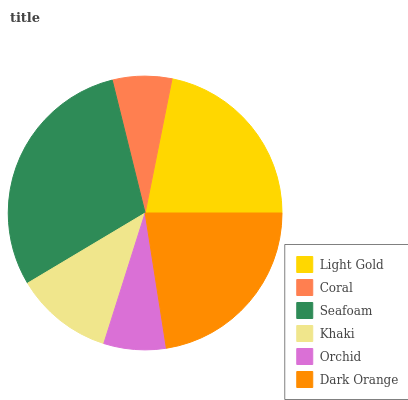Is Coral the minimum?
Answer yes or no. Yes. Is Seafoam the maximum?
Answer yes or no. Yes. Is Seafoam the minimum?
Answer yes or no. No. Is Coral the maximum?
Answer yes or no. No. Is Seafoam greater than Coral?
Answer yes or no. Yes. Is Coral less than Seafoam?
Answer yes or no. Yes. Is Coral greater than Seafoam?
Answer yes or no. No. Is Seafoam less than Coral?
Answer yes or no. No. Is Light Gold the high median?
Answer yes or no. Yes. Is Khaki the low median?
Answer yes or no. Yes. Is Orchid the high median?
Answer yes or no. No. Is Light Gold the low median?
Answer yes or no. No. 